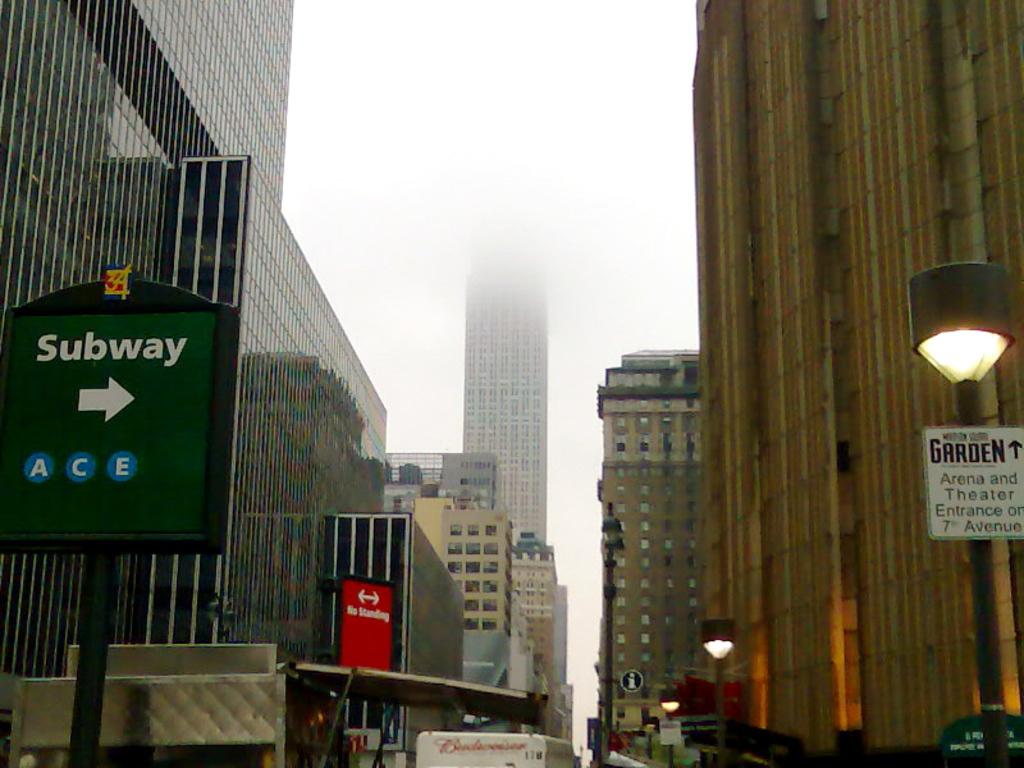What type of structures are visible in the image? There are many buildings in the image. What are the main features of these buildings? The buildings have walls, windows, and glasses. What can be seen on the poles in the image? There are poles with name boards, lamps, and posters in the image. How many crates are stacked on top of each other in the image? There are no crates present in the image. What shape is the circle that is drawn on the poster in the image? There is no circle drawn on any poster in the image. 